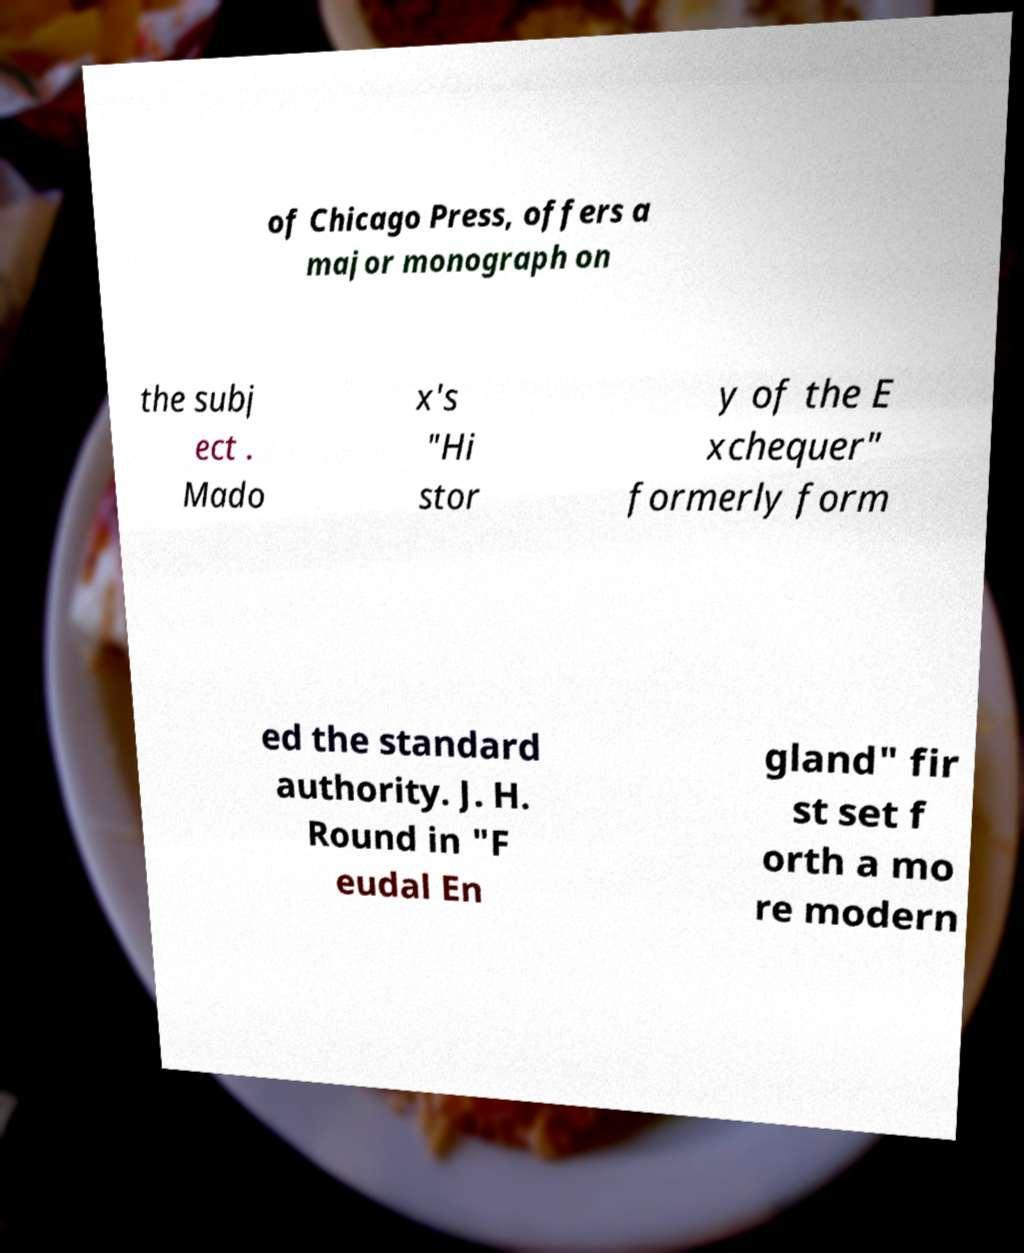For documentation purposes, I need the text within this image transcribed. Could you provide that? of Chicago Press, offers a major monograph on the subj ect . Mado x's "Hi stor y of the E xchequer" formerly form ed the standard authority. J. H. Round in "F eudal En gland" fir st set f orth a mo re modern 